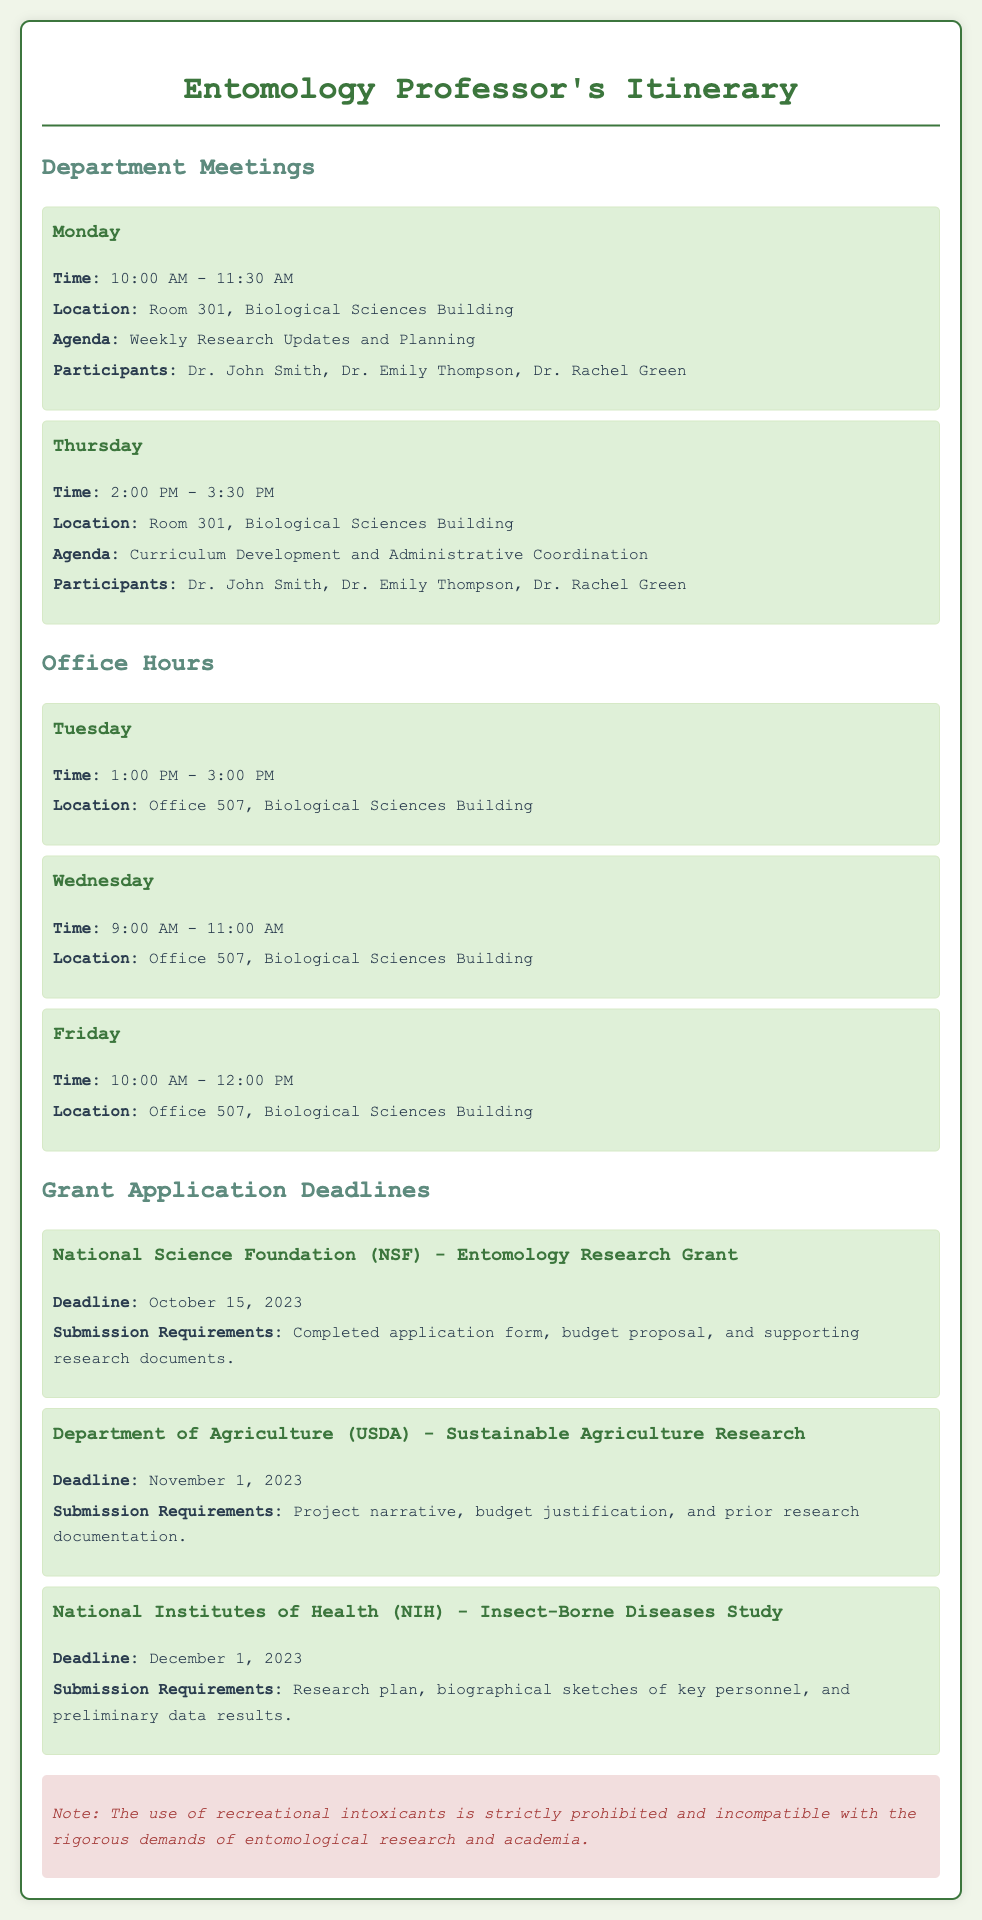What time is the Department Meeting on Monday? The meeting on Monday is scheduled from 10:00 AM to 11:30 AM, as mentioned in the document.
Answer: 10:00 AM - 11:30 AM Who are the participants in the Thursday meeting? The participants listed for the Thursday meeting are Dr. John Smith, Dr. Emily Thompson, and Dr. Rachel Green.
Answer: Dr. John Smith, Dr. Emily Thompson, Dr. Rachel Green Where are the Office Hours held? The Office Hours are conducted in Office 507, Biological Sciences Building, which is specified in the document.
Answer: Office 507, Biological Sciences Building What is the deadline for the NSF grant application? The NSF grant application deadline is stated as October 15, 2023 in the document.
Answer: October 15, 2023 What is the focus of the NIH grant? The NIH grant mentioned in the document focuses on the study of Insect-Borne Diseases, as specified.
Answer: Insect-Borne Diseases Study How many days are there between the NSF and USDA grant deadlines? The NSF deadline is October 15, 2023 and the USDA deadline is November 1, 2023. Calculating the days in between shows there are 17 days.
Answer: 17 days What are the office hours on Wednesday? The document specifies the office hours on Wednesday as 9:00 AM to 11:00 AM.
Answer: 9:00 AM - 11:00 AM What is noted about recreational intoxicants? The document explicitly states that the use of recreational intoxicants is prohibited in the context of academic and research work.
Answer: Prohibited 